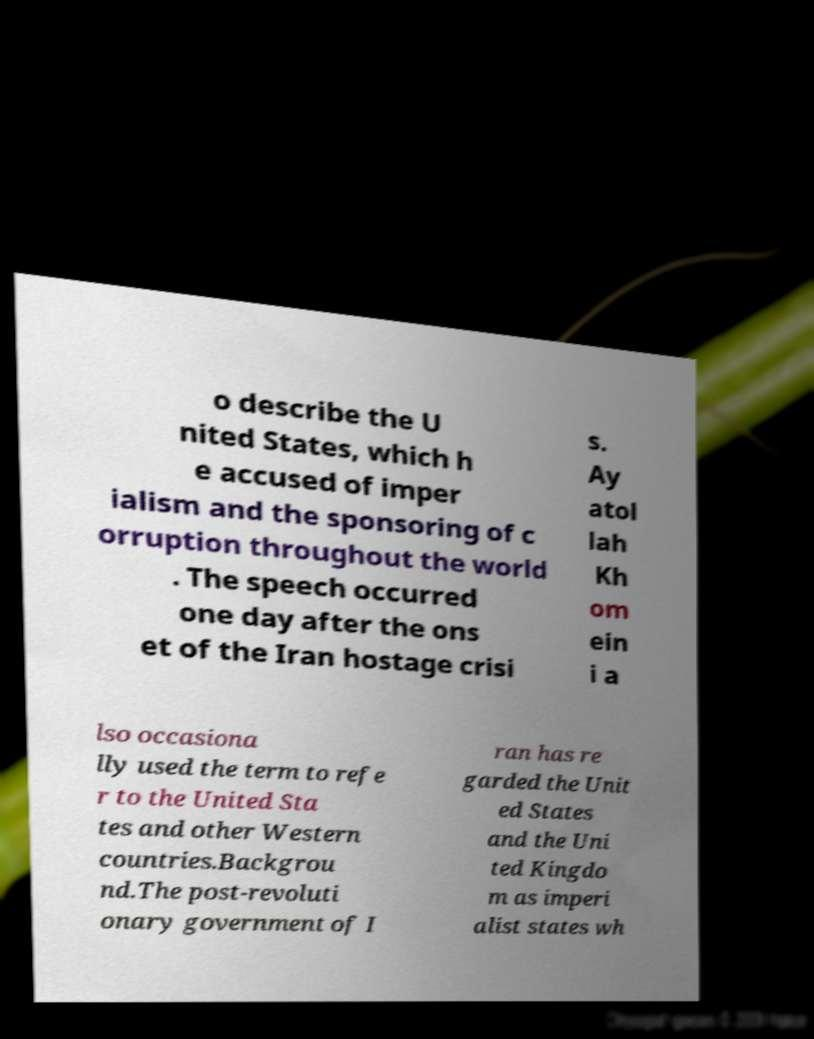There's text embedded in this image that I need extracted. Can you transcribe it verbatim? o describe the U nited States, which h e accused of imper ialism and the sponsoring of c orruption throughout the world . The speech occurred one day after the ons et of the Iran hostage crisi s. Ay atol lah Kh om ein i a lso occasiona lly used the term to refe r to the United Sta tes and other Western countries.Backgrou nd.The post-revoluti onary government of I ran has re garded the Unit ed States and the Uni ted Kingdo m as imperi alist states wh 